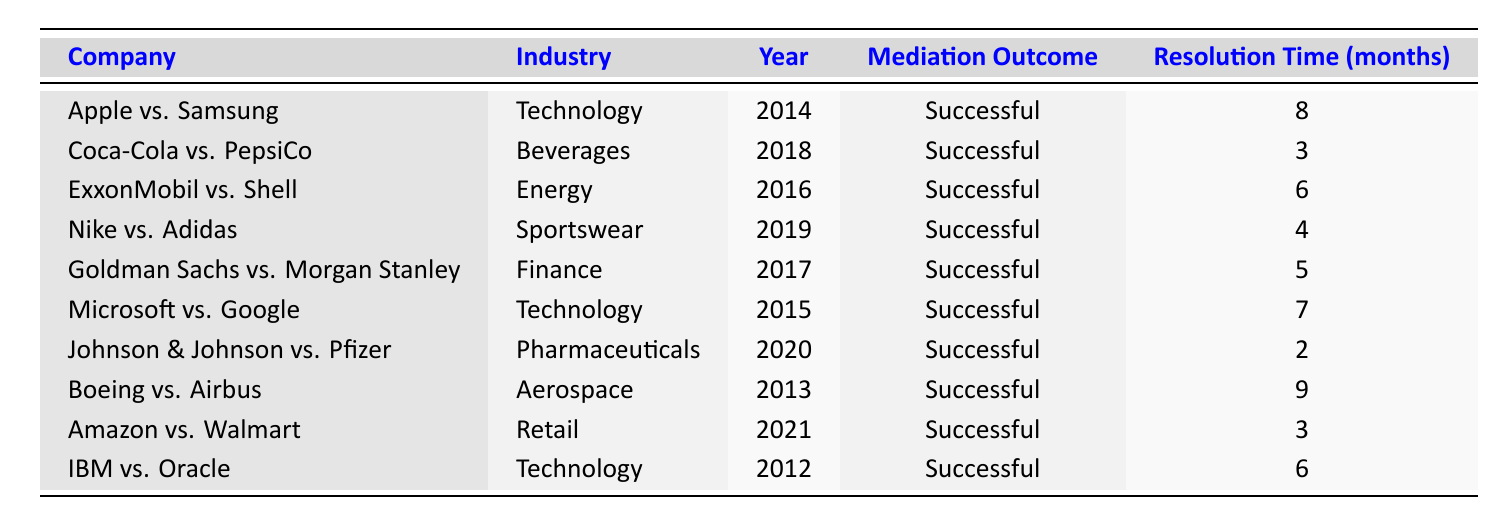What is the resolution time for the dispute between Johnson & Johnson and Pfizer? The table lists the resolution times for each mediation case. For Johnson & Johnson vs. Pfizer, the resolution time is specified as 2 months.
Answer: 2 months Which industry has the longest resolution time, and what is that time? To identify the industry with the longest resolution time, we look at the resolution times across all industries listed. The longest time is for Boeing vs. Airbus in the Aerospace industry, which is noted as 9 months.
Answer: Aerospace, 9 months How many successful mediation cases took place in the Technology industry? By reviewing the table, we see three mediation cases in the Technology industry: Apple vs. Samsung, Microsoft vs. Google, and IBM vs. Oracle. Therefore, there are 3 successful mediation cases in this industry.
Answer: 3 What is the average resolution time for successful mediation cases between the years 2012 to 2016? To find the average resolution time for the years 2012 to 2016, we first list the successful cases from these years: IBM vs. Oracle (6 months), Apple vs. Samsung (8 months), Microsoft vs. Google (7 months), and ExxonMobil vs. Shell (6 months). We sum these times, which totals 27 months, and divide by 4 (number of cases) to get an average of 6.75 months.
Answer: 6.75 months Is it true that Coca-Cola vs. PepsiCo had a shorter resolution time than Nike vs. Adidas? We need to compare the resolution times for both cases. Coca-Cola vs. PepsiCo has a resolution time of 3 months, while Nike vs. Adidas has a resolution time of 4 months. Since 3 months is less than 4 months, the statement is true.
Answer: Yes In which year did the fastest successful mediation case occur, and who were the companies involved? The fastest resolution time is for the case Johnson & Johnson vs. Pfizer, which took 2 months. This case occurred in 2020, making it the fastest successful mediation case listed in the table.
Answer: 2020, Johnson & Johnson vs. Pfizer What is the total resolution time for all successful mediation cases listed in the table? To find the total resolution time, we add all the resolution times in the data: 8 + 3 + 6 + 4 + 5 + 7 + 2 + 9 + 3 + 6 = 53 months. Hence, the total resolution time for all cases is 53 months.
Answer: 53 months 